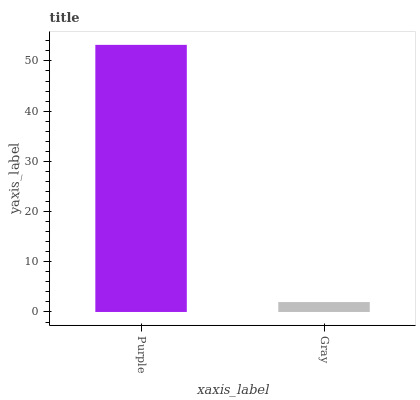Is Gray the minimum?
Answer yes or no. Yes. Is Purple the maximum?
Answer yes or no. Yes. Is Gray the maximum?
Answer yes or no. No. Is Purple greater than Gray?
Answer yes or no. Yes. Is Gray less than Purple?
Answer yes or no. Yes. Is Gray greater than Purple?
Answer yes or no. No. Is Purple less than Gray?
Answer yes or no. No. Is Purple the high median?
Answer yes or no. Yes. Is Gray the low median?
Answer yes or no. Yes. Is Gray the high median?
Answer yes or no. No. Is Purple the low median?
Answer yes or no. No. 